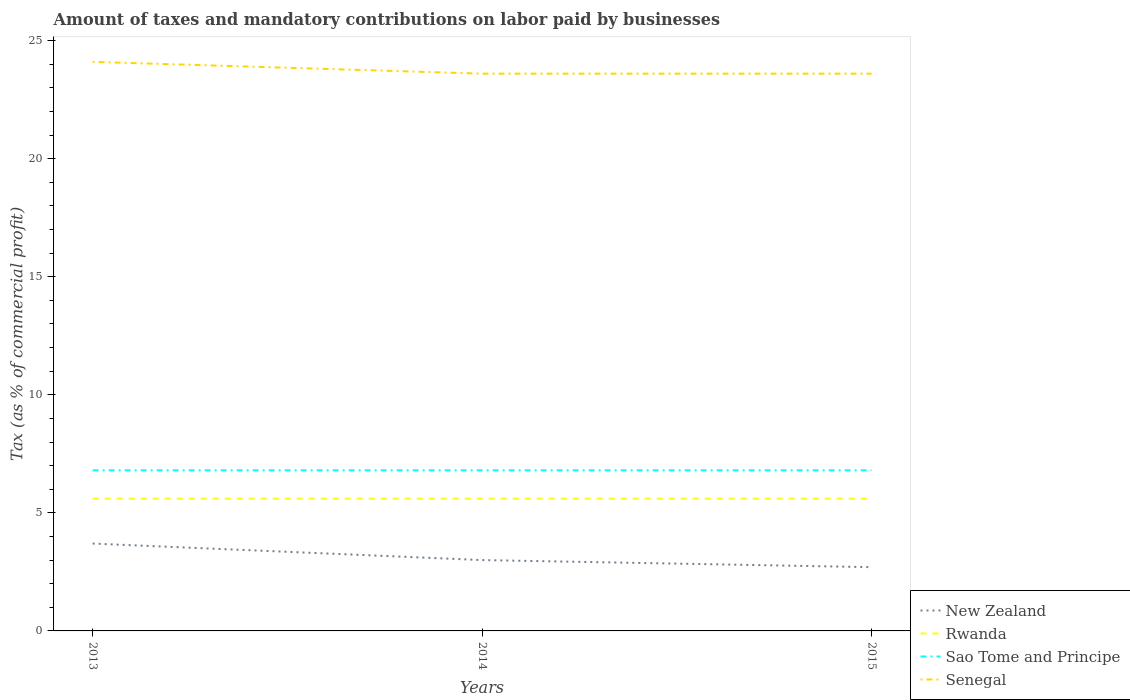How many different coloured lines are there?
Provide a succinct answer. 4. What is the total percentage of taxes paid by businesses in New Zealand in the graph?
Keep it short and to the point. 0.3. What is the difference between the highest and the second highest percentage of taxes paid by businesses in Rwanda?
Provide a short and direct response. 0. What is the difference between the highest and the lowest percentage of taxes paid by businesses in New Zealand?
Your answer should be compact. 1. Is the percentage of taxes paid by businesses in New Zealand strictly greater than the percentage of taxes paid by businesses in Rwanda over the years?
Provide a short and direct response. Yes. How many lines are there?
Provide a short and direct response. 4. What is the difference between two consecutive major ticks on the Y-axis?
Ensure brevity in your answer.  5. Are the values on the major ticks of Y-axis written in scientific E-notation?
Ensure brevity in your answer.  No. Does the graph contain grids?
Make the answer very short. No. How many legend labels are there?
Your response must be concise. 4. What is the title of the graph?
Provide a short and direct response. Amount of taxes and mandatory contributions on labor paid by businesses. What is the label or title of the X-axis?
Keep it short and to the point. Years. What is the label or title of the Y-axis?
Offer a very short reply. Tax (as % of commercial profit). What is the Tax (as % of commercial profit) in Senegal in 2013?
Your answer should be very brief. 24.1. What is the Tax (as % of commercial profit) of Rwanda in 2014?
Your response must be concise. 5.6. What is the Tax (as % of commercial profit) of Senegal in 2014?
Your answer should be compact. 23.6. What is the Tax (as % of commercial profit) of Rwanda in 2015?
Provide a short and direct response. 5.6. What is the Tax (as % of commercial profit) of Sao Tome and Principe in 2015?
Make the answer very short. 6.8. What is the Tax (as % of commercial profit) in Senegal in 2015?
Your answer should be compact. 23.6. Across all years, what is the maximum Tax (as % of commercial profit) in Sao Tome and Principe?
Your answer should be compact. 6.8. Across all years, what is the maximum Tax (as % of commercial profit) in Senegal?
Provide a succinct answer. 24.1. Across all years, what is the minimum Tax (as % of commercial profit) in New Zealand?
Offer a terse response. 2.7. Across all years, what is the minimum Tax (as % of commercial profit) of Rwanda?
Your response must be concise. 5.6. Across all years, what is the minimum Tax (as % of commercial profit) in Senegal?
Give a very brief answer. 23.6. What is the total Tax (as % of commercial profit) of New Zealand in the graph?
Make the answer very short. 9.4. What is the total Tax (as % of commercial profit) in Sao Tome and Principe in the graph?
Your answer should be very brief. 20.4. What is the total Tax (as % of commercial profit) of Senegal in the graph?
Ensure brevity in your answer.  71.3. What is the difference between the Tax (as % of commercial profit) of New Zealand in 2013 and that in 2014?
Provide a short and direct response. 0.7. What is the difference between the Tax (as % of commercial profit) of Rwanda in 2013 and that in 2014?
Your answer should be compact. 0. What is the difference between the Tax (as % of commercial profit) in New Zealand in 2013 and that in 2015?
Offer a terse response. 1. What is the difference between the Tax (as % of commercial profit) in Rwanda in 2014 and that in 2015?
Provide a succinct answer. 0. What is the difference between the Tax (as % of commercial profit) of Senegal in 2014 and that in 2015?
Make the answer very short. 0. What is the difference between the Tax (as % of commercial profit) of New Zealand in 2013 and the Tax (as % of commercial profit) of Senegal in 2014?
Offer a very short reply. -19.9. What is the difference between the Tax (as % of commercial profit) of Sao Tome and Principe in 2013 and the Tax (as % of commercial profit) of Senegal in 2014?
Your response must be concise. -16.8. What is the difference between the Tax (as % of commercial profit) of New Zealand in 2013 and the Tax (as % of commercial profit) of Rwanda in 2015?
Your response must be concise. -1.9. What is the difference between the Tax (as % of commercial profit) of New Zealand in 2013 and the Tax (as % of commercial profit) of Sao Tome and Principe in 2015?
Provide a succinct answer. -3.1. What is the difference between the Tax (as % of commercial profit) in New Zealand in 2013 and the Tax (as % of commercial profit) in Senegal in 2015?
Keep it short and to the point. -19.9. What is the difference between the Tax (as % of commercial profit) of Rwanda in 2013 and the Tax (as % of commercial profit) of Sao Tome and Principe in 2015?
Offer a terse response. -1.2. What is the difference between the Tax (as % of commercial profit) of Rwanda in 2013 and the Tax (as % of commercial profit) of Senegal in 2015?
Make the answer very short. -18. What is the difference between the Tax (as % of commercial profit) in Sao Tome and Principe in 2013 and the Tax (as % of commercial profit) in Senegal in 2015?
Your response must be concise. -16.8. What is the difference between the Tax (as % of commercial profit) of New Zealand in 2014 and the Tax (as % of commercial profit) of Senegal in 2015?
Your response must be concise. -20.6. What is the difference between the Tax (as % of commercial profit) of Sao Tome and Principe in 2014 and the Tax (as % of commercial profit) of Senegal in 2015?
Keep it short and to the point. -16.8. What is the average Tax (as % of commercial profit) in New Zealand per year?
Your response must be concise. 3.13. What is the average Tax (as % of commercial profit) in Sao Tome and Principe per year?
Your response must be concise. 6.8. What is the average Tax (as % of commercial profit) in Senegal per year?
Your answer should be very brief. 23.77. In the year 2013, what is the difference between the Tax (as % of commercial profit) in New Zealand and Tax (as % of commercial profit) in Senegal?
Your response must be concise. -20.4. In the year 2013, what is the difference between the Tax (as % of commercial profit) of Rwanda and Tax (as % of commercial profit) of Senegal?
Give a very brief answer. -18.5. In the year 2013, what is the difference between the Tax (as % of commercial profit) of Sao Tome and Principe and Tax (as % of commercial profit) of Senegal?
Make the answer very short. -17.3. In the year 2014, what is the difference between the Tax (as % of commercial profit) of New Zealand and Tax (as % of commercial profit) of Senegal?
Offer a terse response. -20.6. In the year 2014, what is the difference between the Tax (as % of commercial profit) in Sao Tome and Principe and Tax (as % of commercial profit) in Senegal?
Provide a short and direct response. -16.8. In the year 2015, what is the difference between the Tax (as % of commercial profit) of New Zealand and Tax (as % of commercial profit) of Sao Tome and Principe?
Your answer should be very brief. -4.1. In the year 2015, what is the difference between the Tax (as % of commercial profit) in New Zealand and Tax (as % of commercial profit) in Senegal?
Your response must be concise. -20.9. In the year 2015, what is the difference between the Tax (as % of commercial profit) of Rwanda and Tax (as % of commercial profit) of Sao Tome and Principe?
Make the answer very short. -1.2. In the year 2015, what is the difference between the Tax (as % of commercial profit) of Sao Tome and Principe and Tax (as % of commercial profit) of Senegal?
Your response must be concise. -16.8. What is the ratio of the Tax (as % of commercial profit) of New Zealand in 2013 to that in 2014?
Offer a terse response. 1.23. What is the ratio of the Tax (as % of commercial profit) in Rwanda in 2013 to that in 2014?
Make the answer very short. 1. What is the ratio of the Tax (as % of commercial profit) in Sao Tome and Principe in 2013 to that in 2014?
Your answer should be compact. 1. What is the ratio of the Tax (as % of commercial profit) of Senegal in 2013 to that in 2014?
Provide a succinct answer. 1.02. What is the ratio of the Tax (as % of commercial profit) in New Zealand in 2013 to that in 2015?
Offer a very short reply. 1.37. What is the ratio of the Tax (as % of commercial profit) of Sao Tome and Principe in 2013 to that in 2015?
Keep it short and to the point. 1. What is the ratio of the Tax (as % of commercial profit) of Senegal in 2013 to that in 2015?
Give a very brief answer. 1.02. What is the ratio of the Tax (as % of commercial profit) in Rwanda in 2014 to that in 2015?
Give a very brief answer. 1. What is the ratio of the Tax (as % of commercial profit) of Sao Tome and Principe in 2014 to that in 2015?
Keep it short and to the point. 1. What is the ratio of the Tax (as % of commercial profit) of Senegal in 2014 to that in 2015?
Your answer should be very brief. 1. What is the difference between the highest and the second highest Tax (as % of commercial profit) of New Zealand?
Ensure brevity in your answer.  0.7. What is the difference between the highest and the second highest Tax (as % of commercial profit) of Rwanda?
Offer a very short reply. 0. What is the difference between the highest and the lowest Tax (as % of commercial profit) in New Zealand?
Provide a succinct answer. 1. What is the difference between the highest and the lowest Tax (as % of commercial profit) in Rwanda?
Provide a short and direct response. 0. What is the difference between the highest and the lowest Tax (as % of commercial profit) of Sao Tome and Principe?
Offer a terse response. 0. 